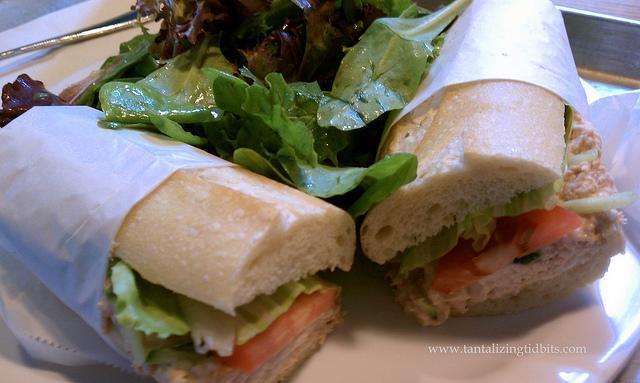How many sandwich on are on the plate?
Give a very brief answer. 2. How many sandwiches are there?
Give a very brief answer. 2. How many black cars are under a cat?
Give a very brief answer. 0. 